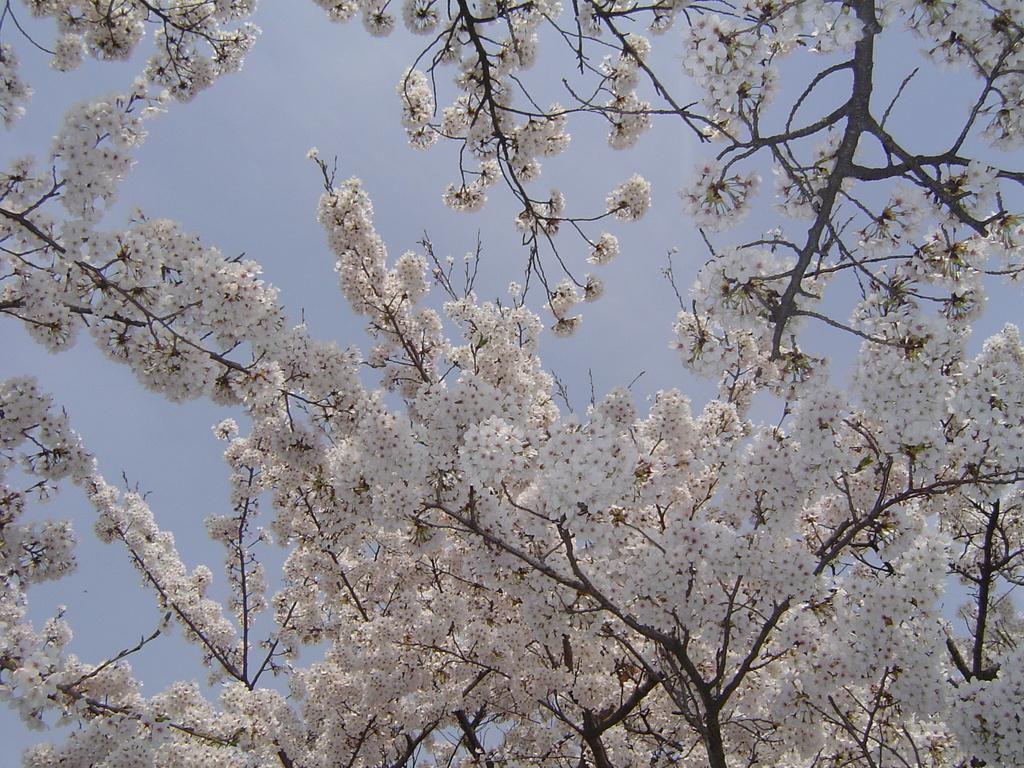What type of tree is present in the image? There is a white color flower tree in the image. What can be seen in the background of the image? The sky is visible in the background of the image. What position does the rod hold in the image? There is no rod present in the image. 